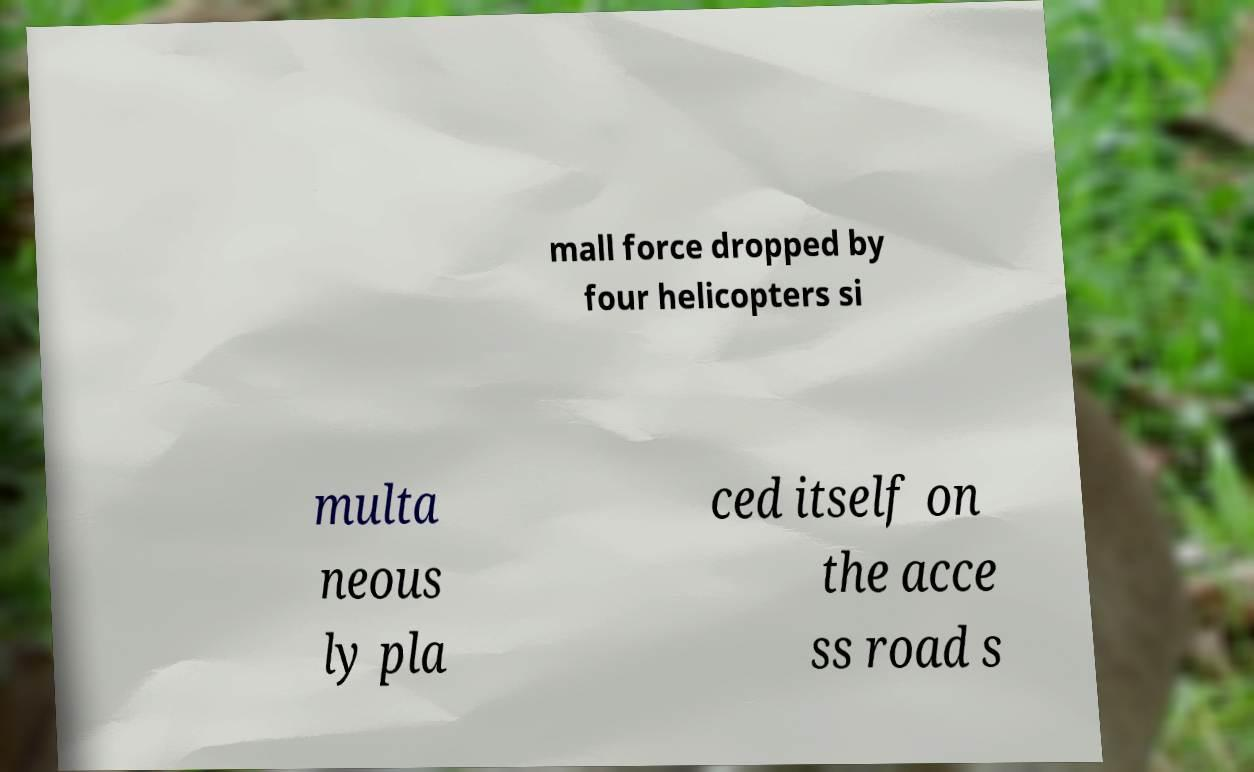I need the written content from this picture converted into text. Can you do that? mall force dropped by four helicopters si multa neous ly pla ced itself on the acce ss road s 